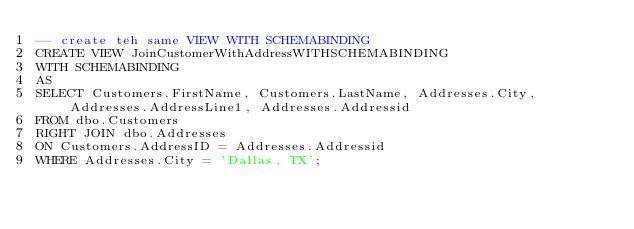Convert code to text. <code><loc_0><loc_0><loc_500><loc_500><_SQL_>-- create teh same VIEW WITH SCHEMABINDING
CREATE VIEW JoinCustomerWithAddressWITHSCHEMABINDING 
WITH SCHEMABINDING
AS
SELECT Customers.FirstName, Customers.LastName, Addresses.City, Addresses.AddressLine1, Addresses.Addressid
FROM dbo.Customers
RIGHT JOIN dbo.Addresses 
ON Customers.AddressID = Addresses.Addressid
WHERE Addresses.City = 'Dallas, TX';
</code> 